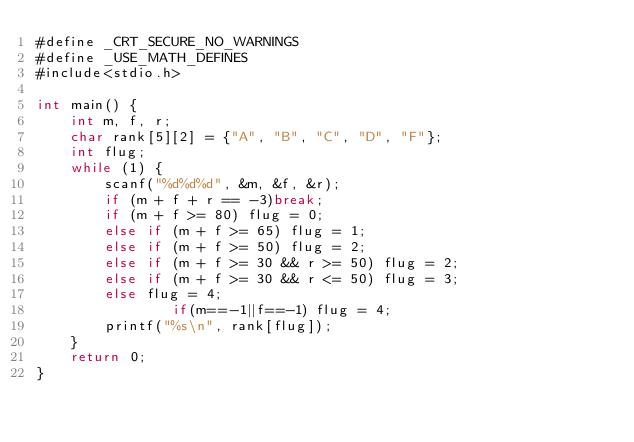Convert code to text. <code><loc_0><loc_0><loc_500><loc_500><_C#_>#define _CRT_SECURE_NO_WARNINGS
#define _USE_MATH_DEFINES
#include<stdio.h>

int main() {
	int m, f, r;
	char rank[5][2] = {"A", "B", "C", "D", "F"};
	int flug;
	while (1) {
		scanf("%d%d%d", &m, &f, &r);
		if (m + f + r == -3)break;
		if (m + f >= 80) flug = 0;
		else if (m + f >= 65) flug = 1;
		else if (m + f >= 50) flug = 2;
		else if (m + f >= 30 && r >= 50) flug = 2;
		else if (m + f >= 30 && r <= 50) flug = 3;
		else flug = 4;
                if(m==-1||f==-1) flug = 4;
		printf("%s\n", rank[flug]);
	}
	return 0;
}</code> 